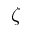Convert formula to latex. <formula><loc_0><loc_0><loc_500><loc_500>\zeta</formula> 